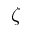Convert formula to latex. <formula><loc_0><loc_0><loc_500><loc_500>\zeta</formula> 